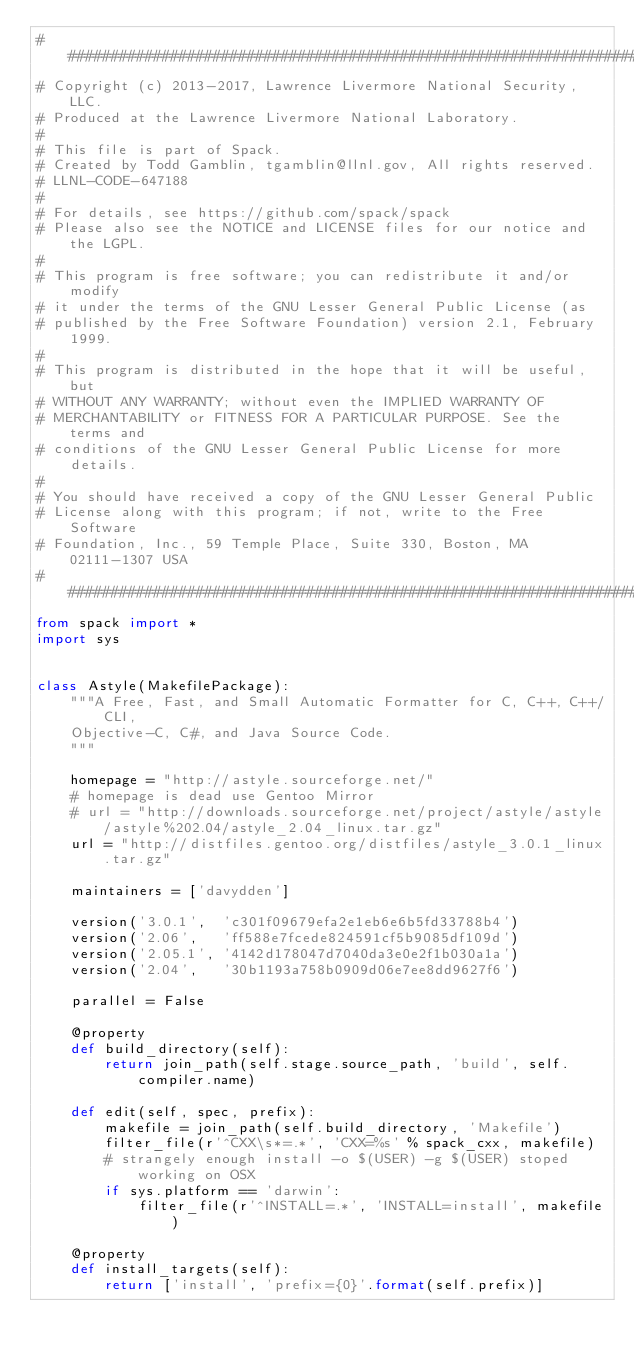<code> <loc_0><loc_0><loc_500><loc_500><_Python_>##############################################################################
# Copyright (c) 2013-2017, Lawrence Livermore National Security, LLC.
# Produced at the Lawrence Livermore National Laboratory.
#
# This file is part of Spack.
# Created by Todd Gamblin, tgamblin@llnl.gov, All rights reserved.
# LLNL-CODE-647188
#
# For details, see https://github.com/spack/spack
# Please also see the NOTICE and LICENSE files for our notice and the LGPL.
#
# This program is free software; you can redistribute it and/or modify
# it under the terms of the GNU Lesser General Public License (as
# published by the Free Software Foundation) version 2.1, February 1999.
#
# This program is distributed in the hope that it will be useful, but
# WITHOUT ANY WARRANTY; without even the IMPLIED WARRANTY OF
# MERCHANTABILITY or FITNESS FOR A PARTICULAR PURPOSE. See the terms and
# conditions of the GNU Lesser General Public License for more details.
#
# You should have received a copy of the GNU Lesser General Public
# License along with this program; if not, write to the Free Software
# Foundation, Inc., 59 Temple Place, Suite 330, Boston, MA 02111-1307 USA
##############################################################################
from spack import *
import sys


class Astyle(MakefilePackage):
    """A Free, Fast, and Small Automatic Formatter for C, C++, C++/CLI,
    Objective-C, C#, and Java Source Code.
    """

    homepage = "http://astyle.sourceforge.net/"
    # homepage is dead use Gentoo Mirror
    # url = "http://downloads.sourceforge.net/project/astyle/astyle/astyle%202.04/astyle_2.04_linux.tar.gz"
    url = "http://distfiles.gentoo.org/distfiles/astyle_3.0.1_linux.tar.gz"

    maintainers = ['davydden']

    version('3.0.1',  'c301f09679efa2e1eb6e6b5fd33788b4')
    version('2.06',   'ff588e7fcede824591cf5b9085df109d')
    version('2.05.1', '4142d178047d7040da3e0e2f1b030a1a')
    version('2.04',   '30b1193a758b0909d06e7ee8dd9627f6')

    parallel = False

    @property
    def build_directory(self):
        return join_path(self.stage.source_path, 'build', self.compiler.name)

    def edit(self, spec, prefix):
        makefile = join_path(self.build_directory, 'Makefile')
        filter_file(r'^CXX\s*=.*', 'CXX=%s' % spack_cxx, makefile)
        # strangely enough install -o $(USER) -g $(USER) stoped working on OSX
        if sys.platform == 'darwin':
            filter_file(r'^INSTALL=.*', 'INSTALL=install', makefile)

    @property
    def install_targets(self):
        return ['install', 'prefix={0}'.format(self.prefix)]
</code> 